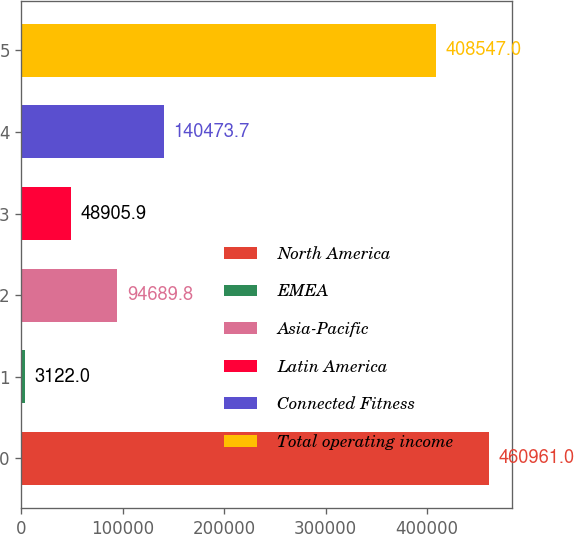Convert chart to OTSL. <chart><loc_0><loc_0><loc_500><loc_500><bar_chart><fcel>North America<fcel>EMEA<fcel>Asia-Pacific<fcel>Latin America<fcel>Connected Fitness<fcel>Total operating income<nl><fcel>460961<fcel>3122<fcel>94689.8<fcel>48905.9<fcel>140474<fcel>408547<nl></chart> 